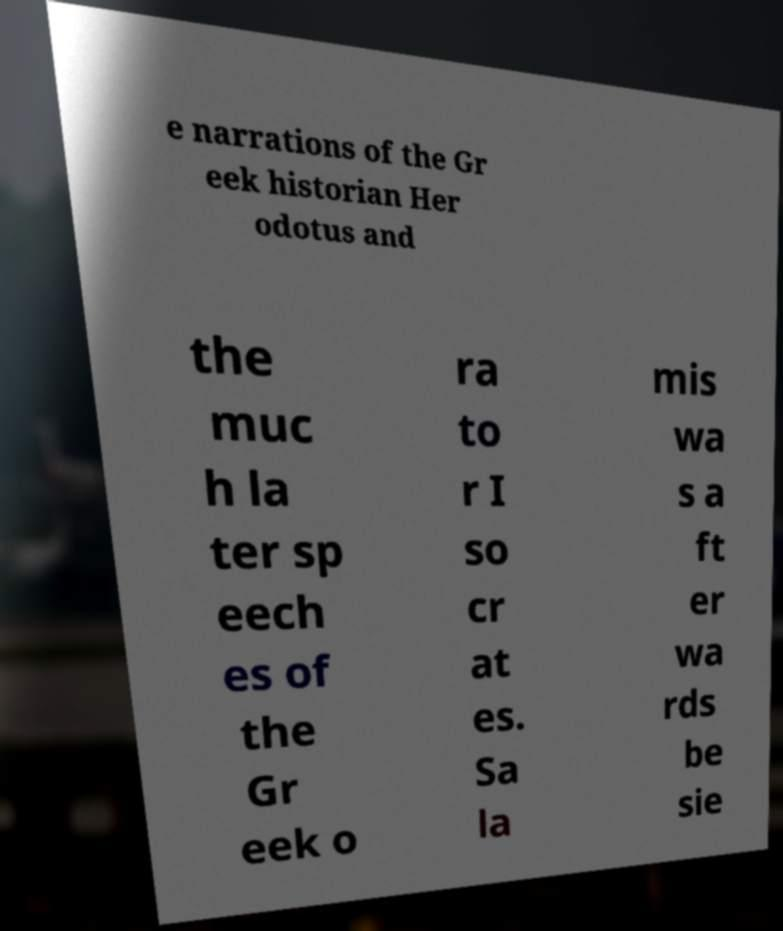Can you read and provide the text displayed in the image?This photo seems to have some interesting text. Can you extract and type it out for me? e narrations of the Gr eek historian Her odotus and the muc h la ter sp eech es of the Gr eek o ra to r I so cr at es. Sa la mis wa s a ft er wa rds be sie 